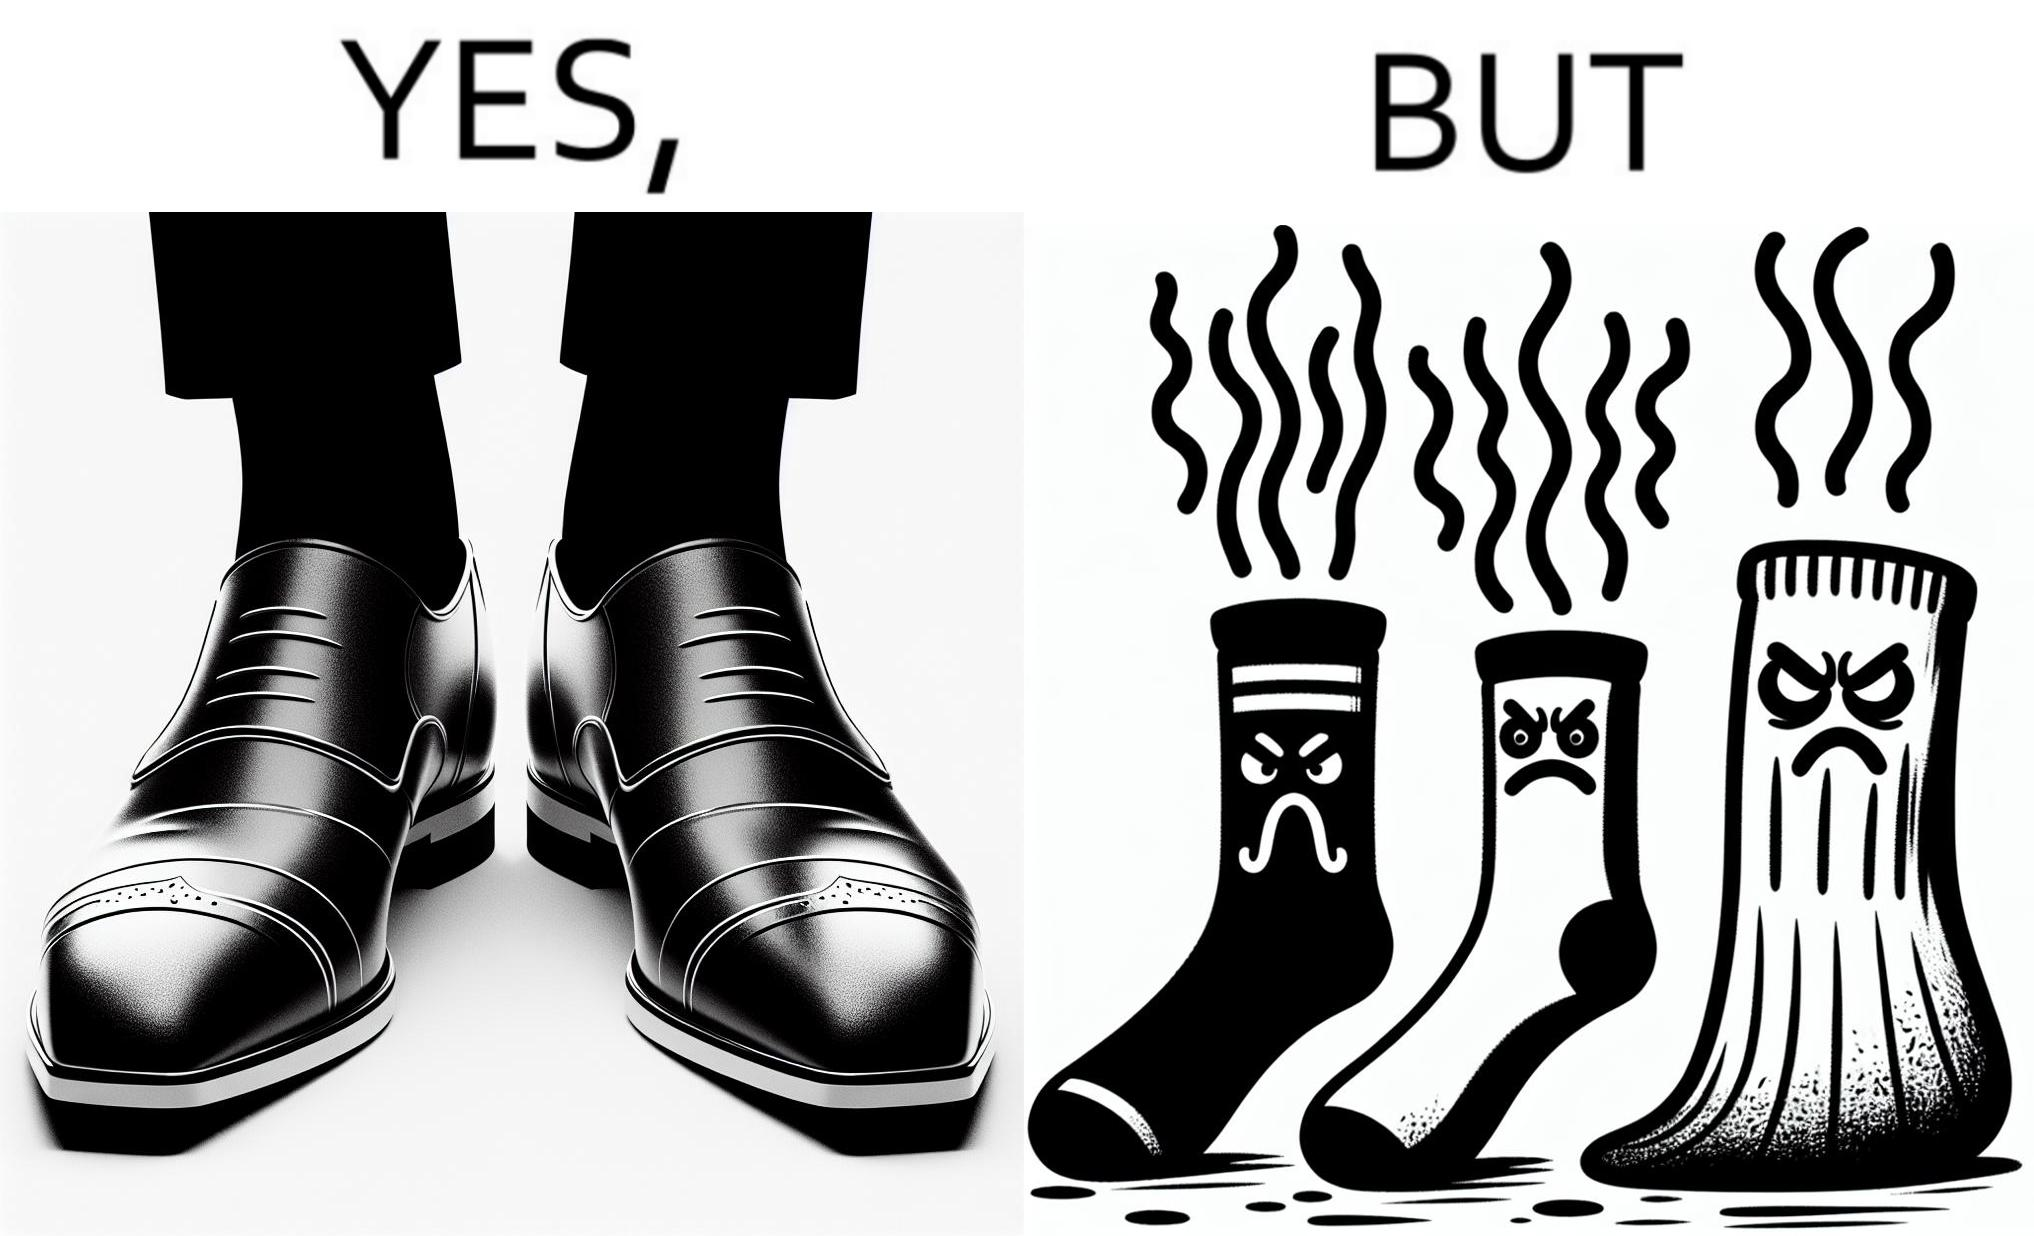Compare the left and right sides of this image. In the left part of the image: The image is showing neat and clean shoes. In the right part of the image: The image is showing dirty shocks. 